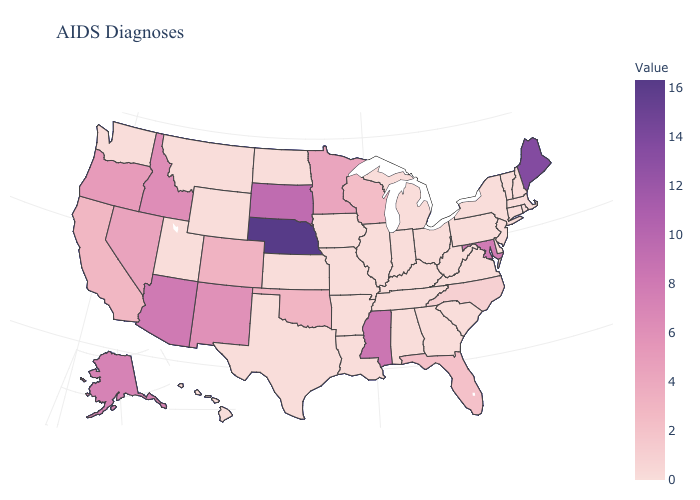Does Nebraska have the highest value in the USA?
Short answer required. Yes. Which states have the highest value in the USA?
Give a very brief answer. Nebraska. Which states hav the highest value in the West?
Concise answer only. Arizona. Which states have the lowest value in the USA?
Quick response, please. Alabama, Arkansas, Connecticut, Delaware, Georgia, Hawaii, Illinois, Indiana, Iowa, Kansas, Kentucky, Louisiana, Massachusetts, Michigan, Missouri, Montana, New Hampshire, New Jersey, New York, North Dakota, Ohio, Pennsylvania, Rhode Island, South Carolina, Tennessee, Texas, Utah, Vermont, Virginia, Washington, West Virginia, Wyoming. 